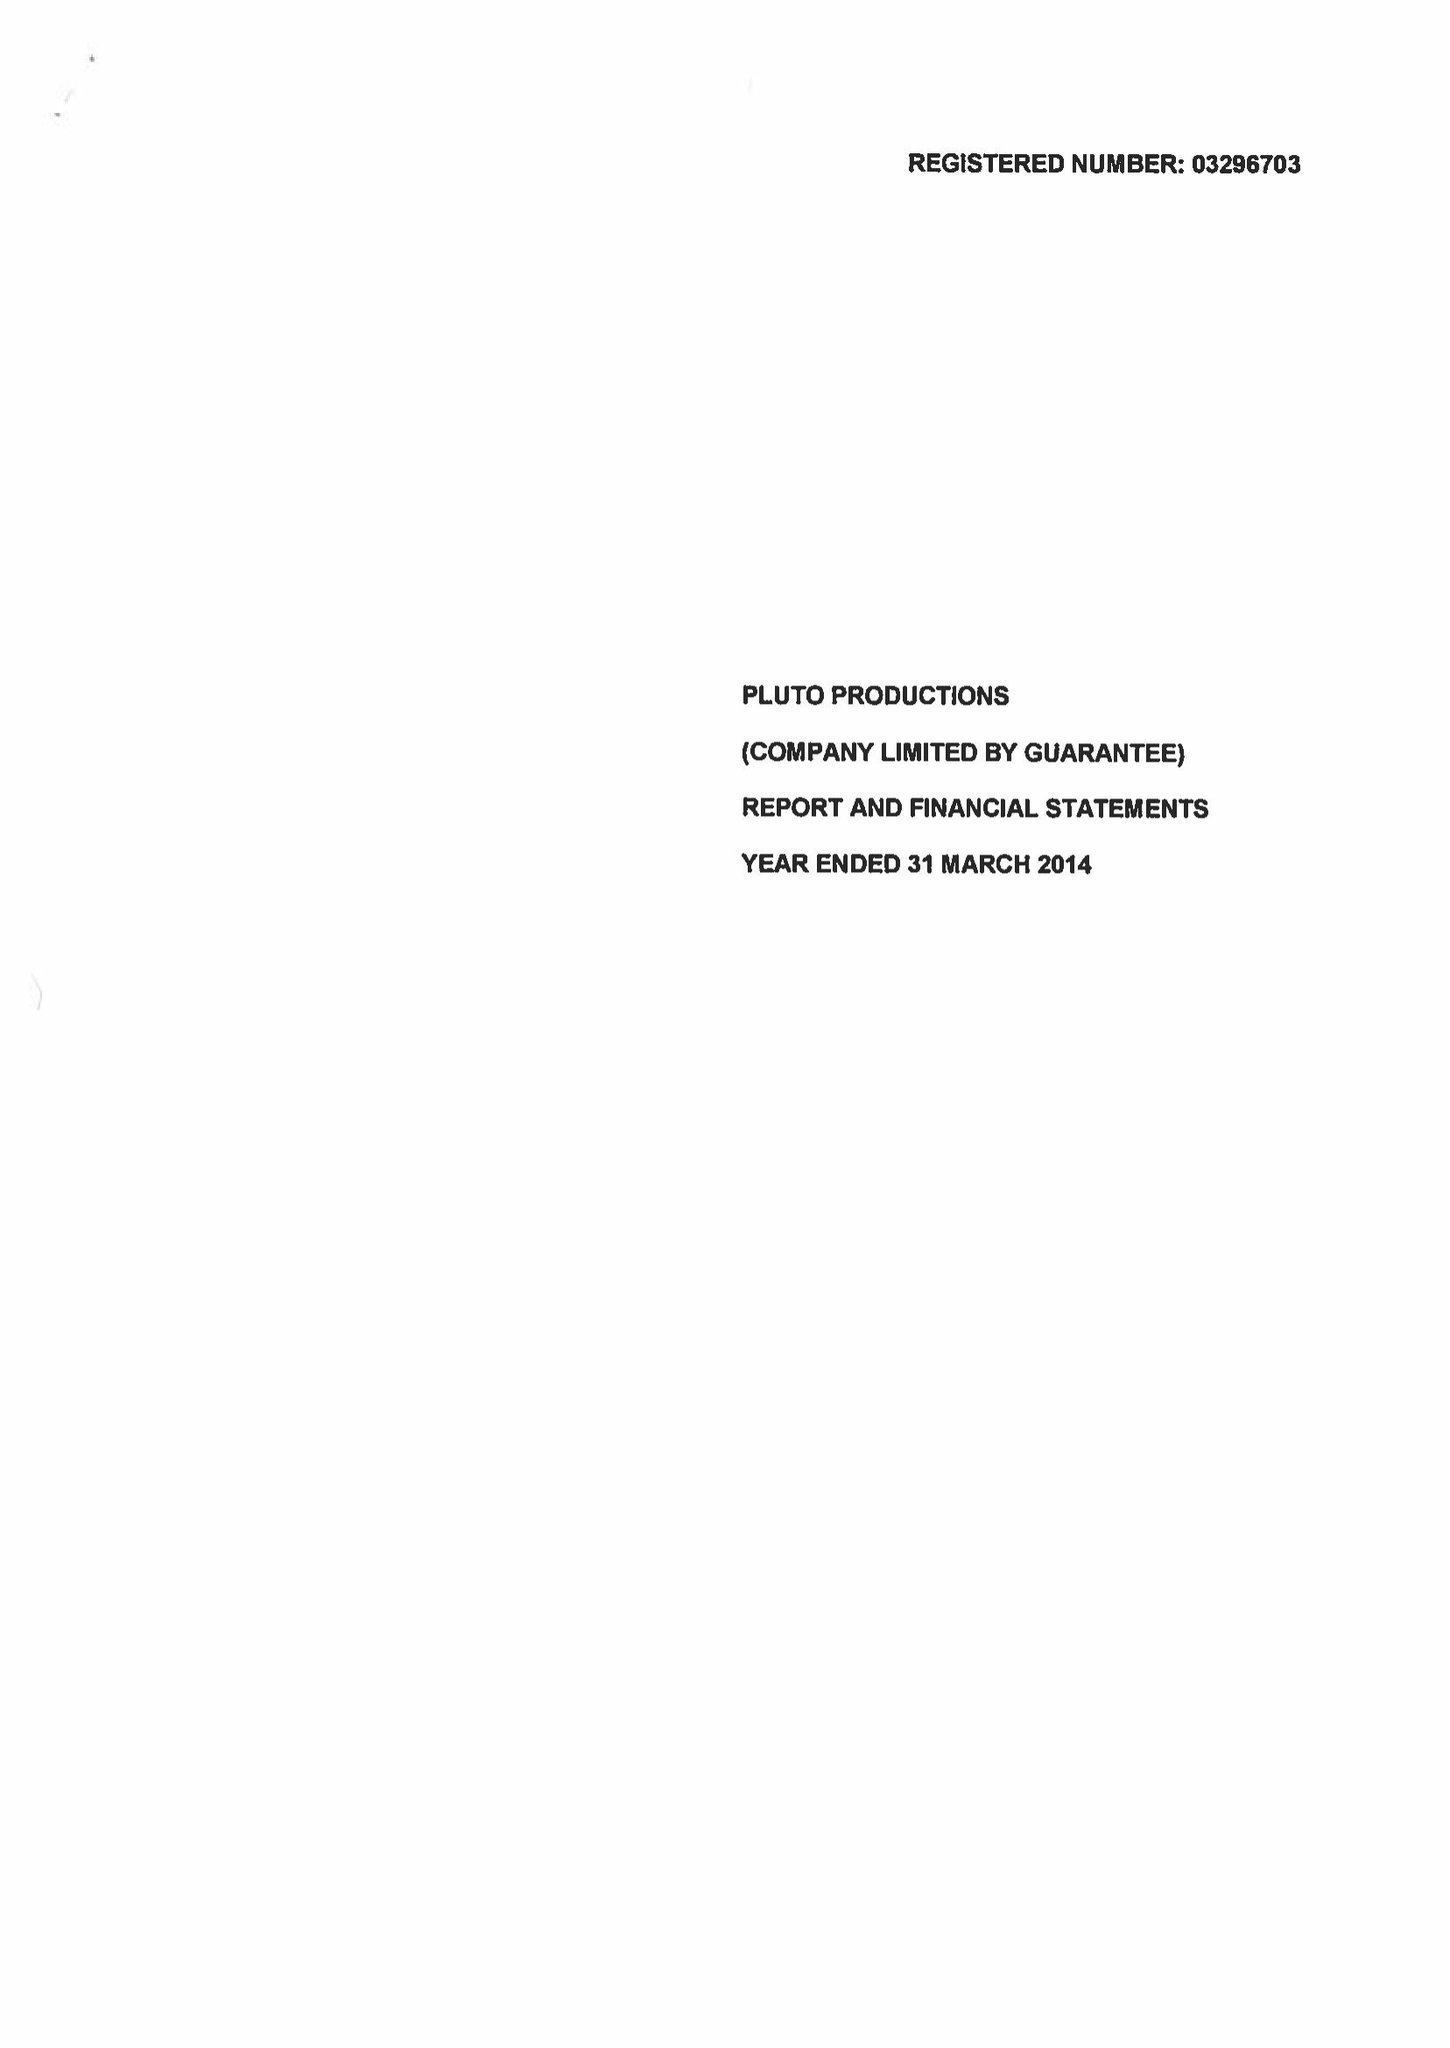What is the value for the charity_name?
Answer the question using a single word or phrase. Pluto Productions 